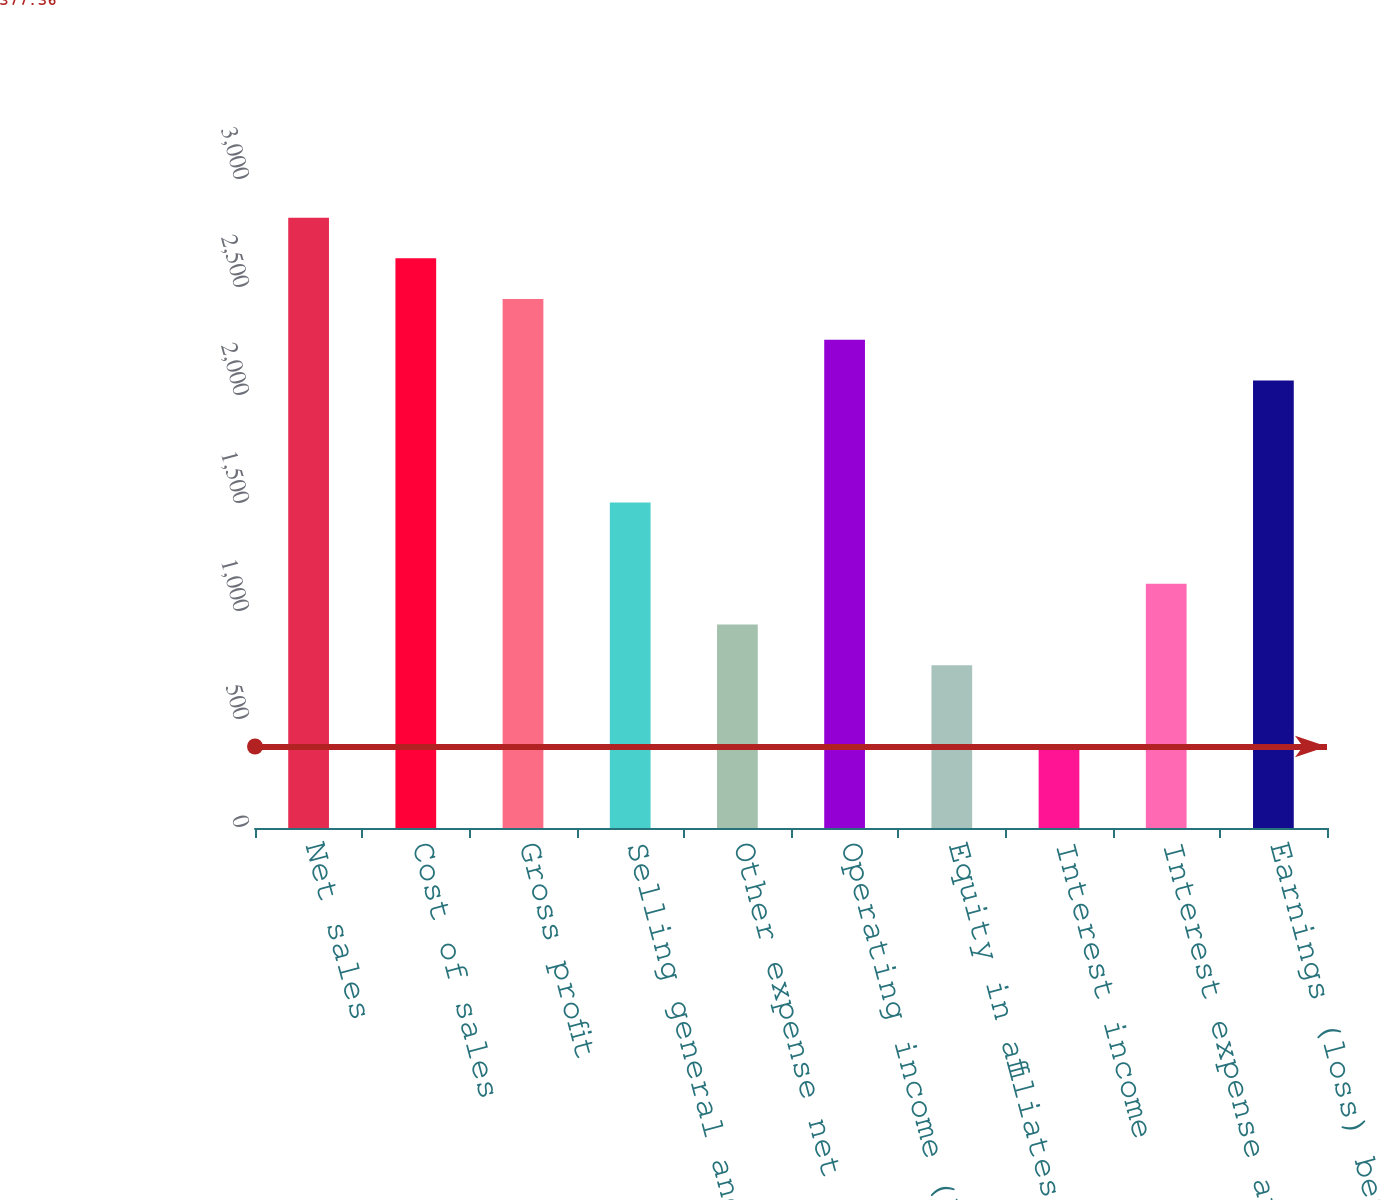Convert chart. <chart><loc_0><loc_0><loc_500><loc_500><bar_chart><fcel>Net sales<fcel>Cost of sales<fcel>Gross profit<fcel>Selling general and<fcel>Other expense net<fcel>Operating income (loss)<fcel>Equity in affiliates' earnings<fcel>Interest income<fcel>Interest expense and finance<fcel>Earnings (loss) before income<nl><fcel>2825.65<fcel>2637.32<fcel>2448.99<fcel>1507.34<fcel>942.35<fcel>2260.66<fcel>754.02<fcel>377.36<fcel>1130.68<fcel>2072.33<nl></chart> 